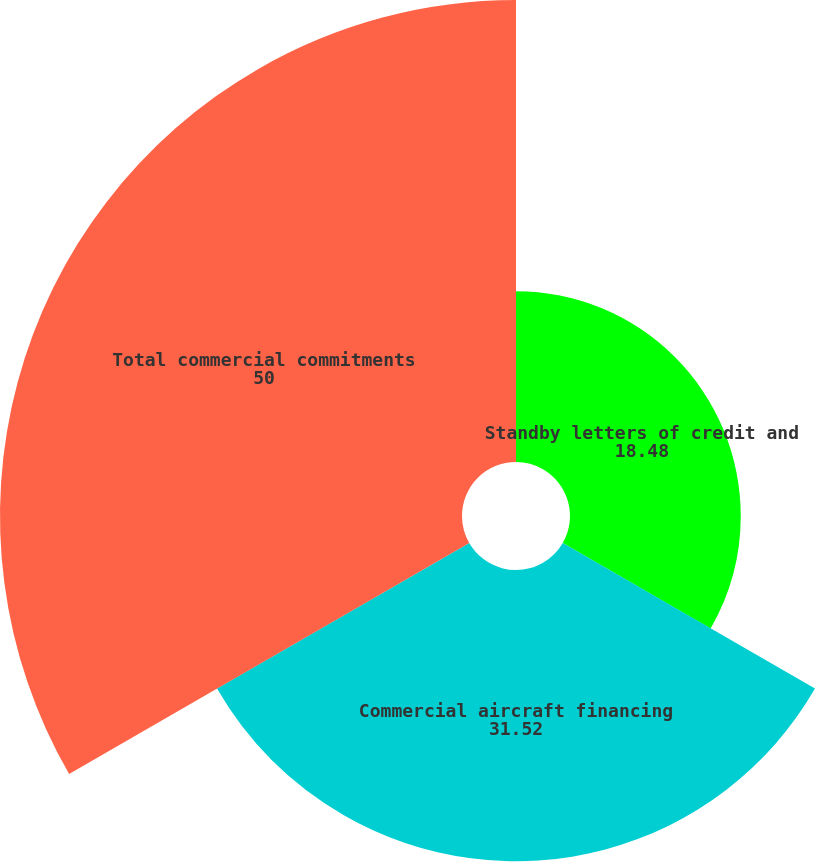Convert chart. <chart><loc_0><loc_0><loc_500><loc_500><pie_chart><fcel>Standby letters of credit and<fcel>Commercial aircraft financing<fcel>Total commercial commitments<nl><fcel>18.48%<fcel>31.52%<fcel>50.0%<nl></chart> 